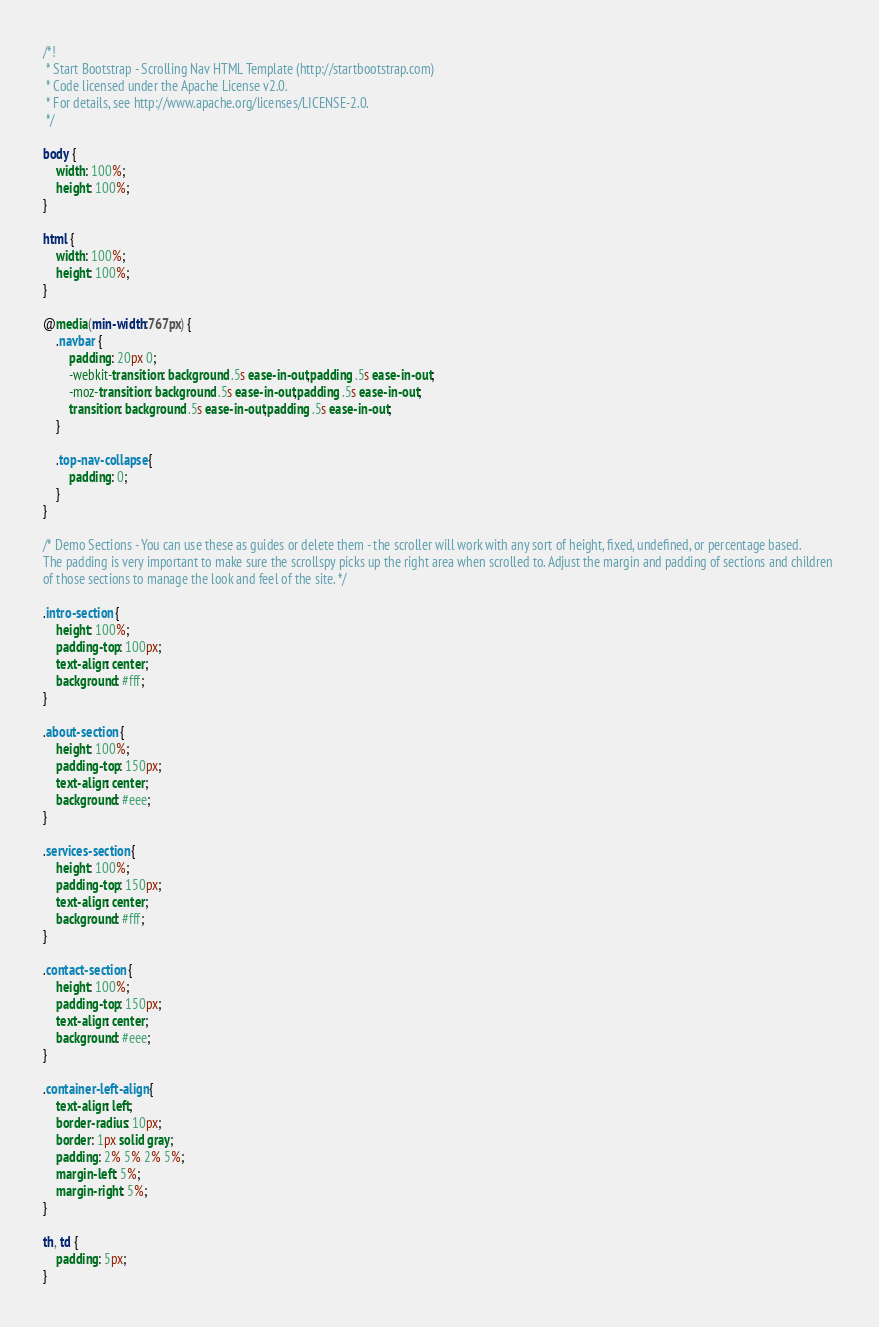Convert code to text. <code><loc_0><loc_0><loc_500><loc_500><_CSS_>/*!
 * Start Bootstrap - Scrolling Nav HTML Template (http://startbootstrap.com)
 * Code licensed under the Apache License v2.0.
 * For details, see http://www.apache.org/licenses/LICENSE-2.0.
 */

body {
    width: 100%;
    height: 100%;
}

html {
    width: 100%;
    height: 100%;
}

@media(min-width:767px) {
    .navbar {
        padding: 20px 0;
        -webkit-transition: background .5s ease-in-out,padding .5s ease-in-out;
        -moz-transition: background .5s ease-in-out,padding .5s ease-in-out;
        transition: background .5s ease-in-out,padding .5s ease-in-out;
    }

    .top-nav-collapse {
        padding: 0;
    }
}

/* Demo Sections - You can use these as guides or delete them - the scroller will work with any sort of height, fixed, undefined, or percentage based.
The padding is very important to make sure the scrollspy picks up the right area when scrolled to. Adjust the margin and padding of sections and children 
of those sections to manage the look and feel of the site. */

.intro-section {
    height: 100%;
    padding-top: 100px;
    text-align: center;
    background: #fff;
}

.about-section {
    height: 100%;
    padding-top: 150px;
    text-align: center;
    background: #eee;
}

.services-section {
    height: 100%;
    padding-top: 150px;
    text-align: center;
    background: #fff;
}

.contact-section {
    height: 100%;
    padding-top: 150px;
    text-align: center;
    background: #eee;
}

.container-left-align {
    text-align: left;
    border-radius: 10px;
    border: 1px solid gray;
    padding: 2% 5% 2% 5%; 
    margin-left: 5%;
    margin-right: 5%;
}

th, td {
    padding: 5px;
}</code> 